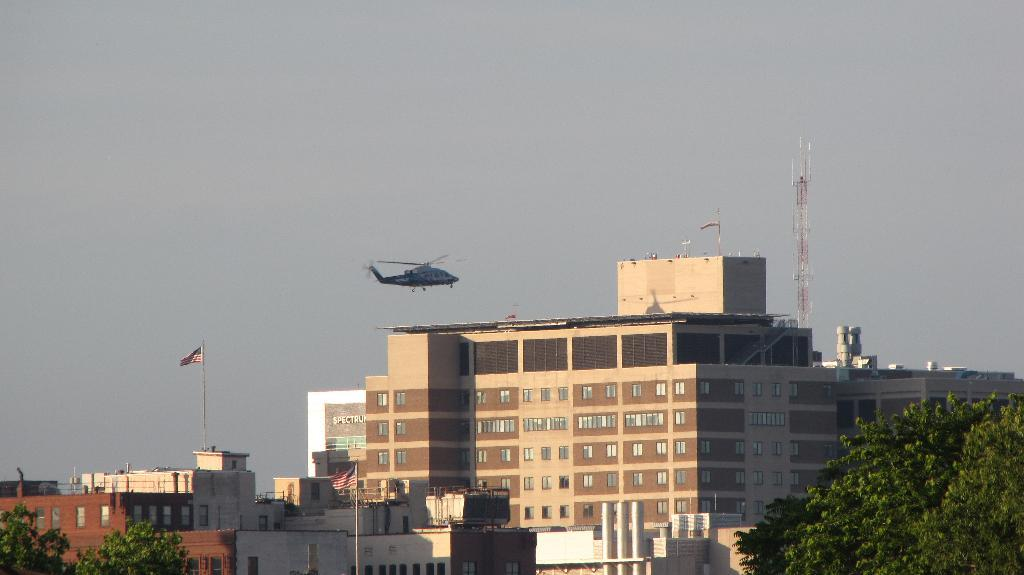What is the main subject of the image? The main subject of the image is an airplane flying. What else can be seen in the image besides the airplane? There are buildings, trees, flags, and a tower visible in the image. What is the background of the image? The sky is visible in the background of the image. What type of bag is being used to play a trick on the airplane in the image? There is no bag or trick involving the airplane in the image; it is simply flying in the sky. 